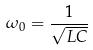<formula> <loc_0><loc_0><loc_500><loc_500>\omega _ { 0 } = \frac { 1 } { \sqrt { L C } }</formula> 